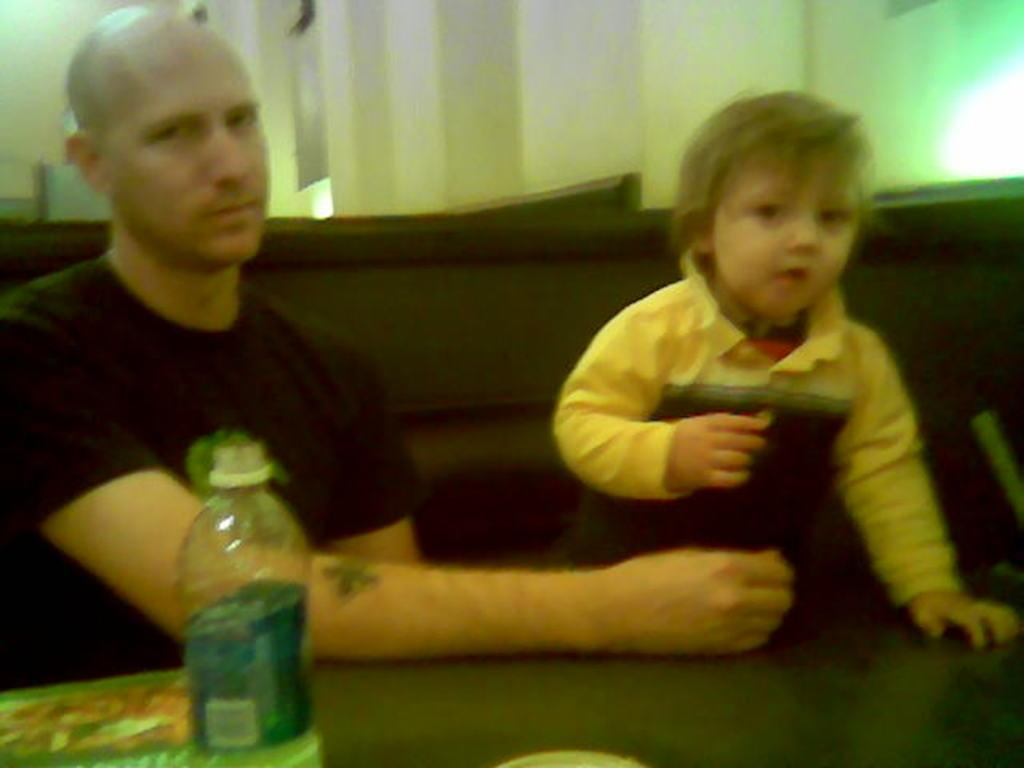Who is present in the image? There is a man and a child in the image. What object can be seen in the image? There is a water bottle in the image. What type of string is the dog playing with in the image? There is no dog or string present in the image. 